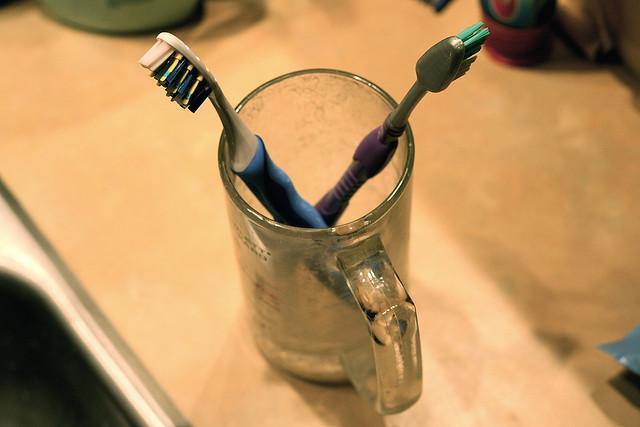How many toothbrushes can you see?
Give a very brief answer. 2. How many cups can be seen?
Give a very brief answer. 2. How many sinks can you see?
Give a very brief answer. 1. 